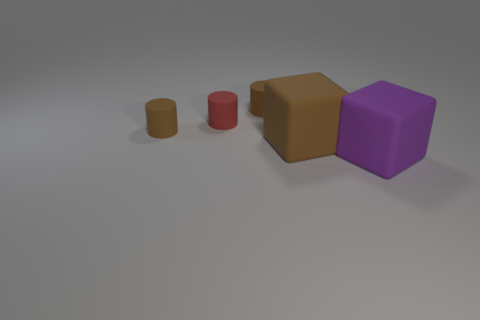Are there any other large objects that have the same shape as the large purple rubber object?
Offer a very short reply. Yes. There is a large matte block that is behind the big purple object that is right of the red rubber object; what is its color?
Give a very brief answer. Brown. Is the number of big purple cubes greater than the number of rubber objects?
Your answer should be compact. No. How many other purple rubber objects have the same size as the purple matte thing?
Ensure brevity in your answer.  0. Are the purple object and the big thing that is behind the big purple rubber thing made of the same material?
Offer a terse response. Yes. Are there fewer large purple rubber objects than small objects?
Your response must be concise. Yes. What shape is the big object that is the same material as the purple block?
Ensure brevity in your answer.  Cube. There is a cube to the right of the big thing left of the big purple matte thing; what number of matte cylinders are in front of it?
Keep it short and to the point. 0. What shape is the brown rubber thing that is behind the brown matte cube and in front of the red rubber cylinder?
Make the answer very short. Cylinder. Is the number of purple matte cubes that are on the left side of the purple block less than the number of metal cubes?
Keep it short and to the point. No. 